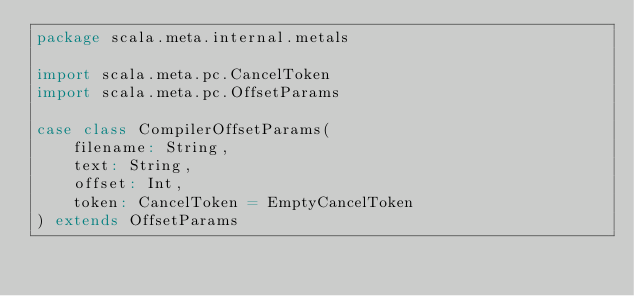<code> <loc_0><loc_0><loc_500><loc_500><_Scala_>package scala.meta.internal.metals

import scala.meta.pc.CancelToken
import scala.meta.pc.OffsetParams

case class CompilerOffsetParams(
    filename: String,
    text: String,
    offset: Int,
    token: CancelToken = EmptyCancelToken
) extends OffsetParams
</code> 